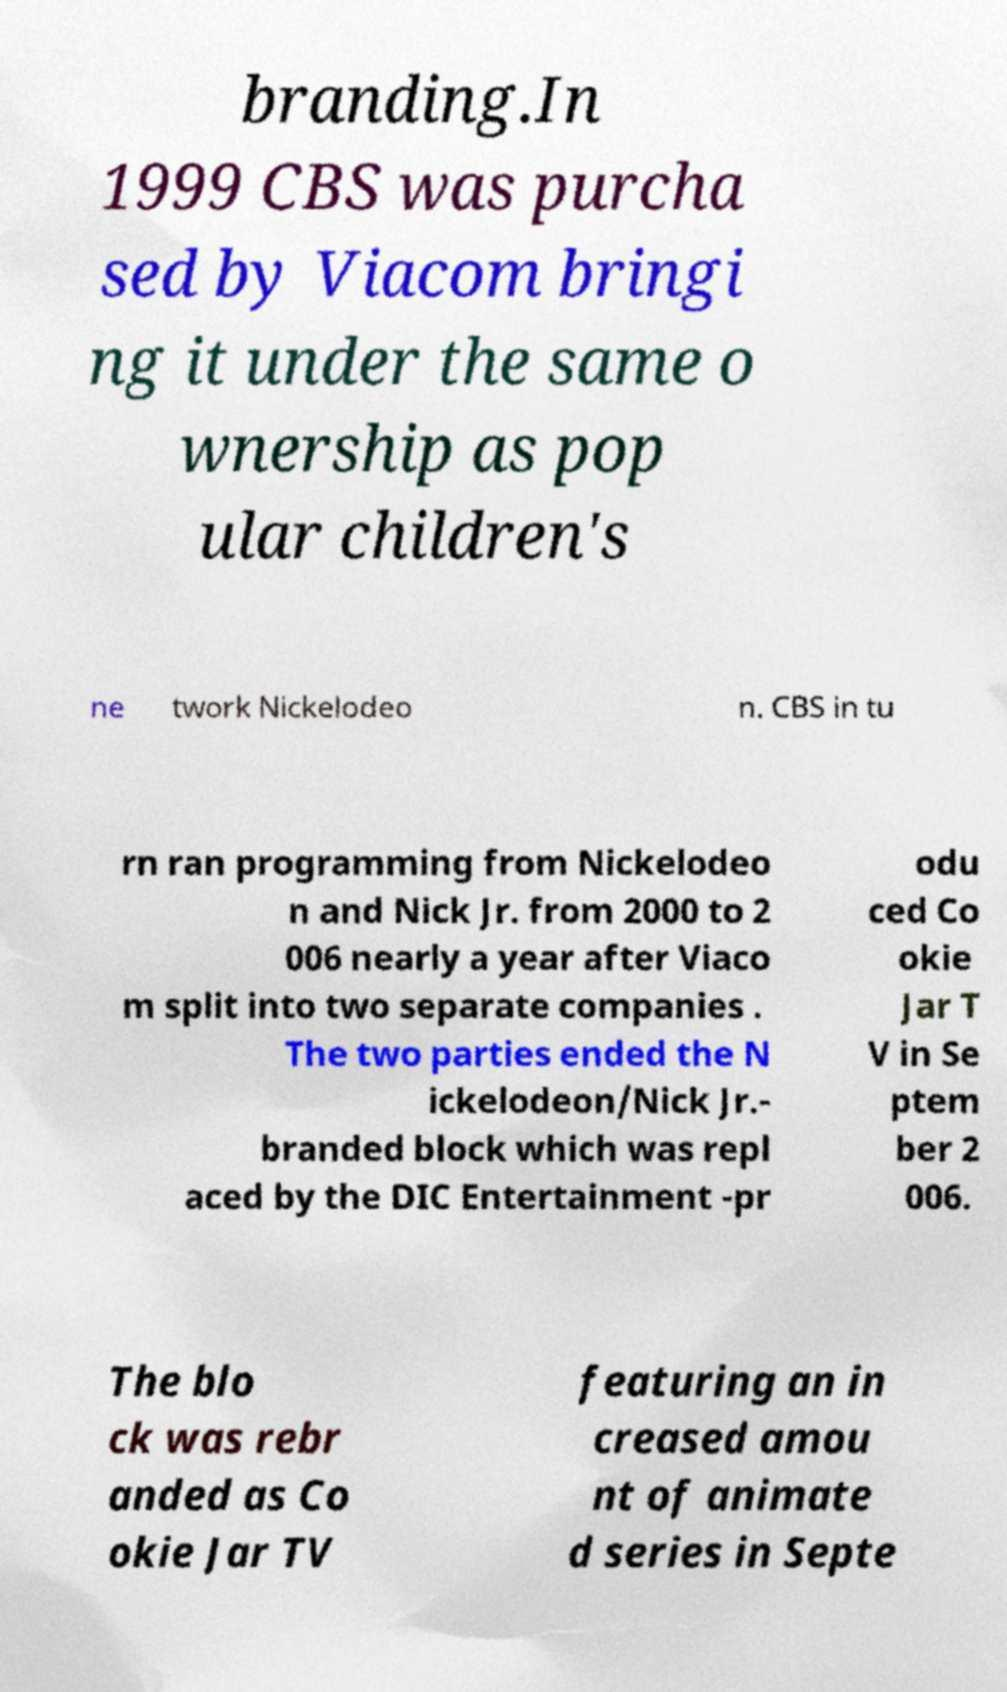Please identify and transcribe the text found in this image. branding.In 1999 CBS was purcha sed by Viacom bringi ng it under the same o wnership as pop ular children's ne twork Nickelodeo n. CBS in tu rn ran programming from Nickelodeo n and Nick Jr. from 2000 to 2 006 nearly a year after Viaco m split into two separate companies . The two parties ended the N ickelodeon/Nick Jr.- branded block which was repl aced by the DIC Entertainment -pr odu ced Co okie Jar T V in Se ptem ber 2 006. The blo ck was rebr anded as Co okie Jar TV featuring an in creased amou nt of animate d series in Septe 